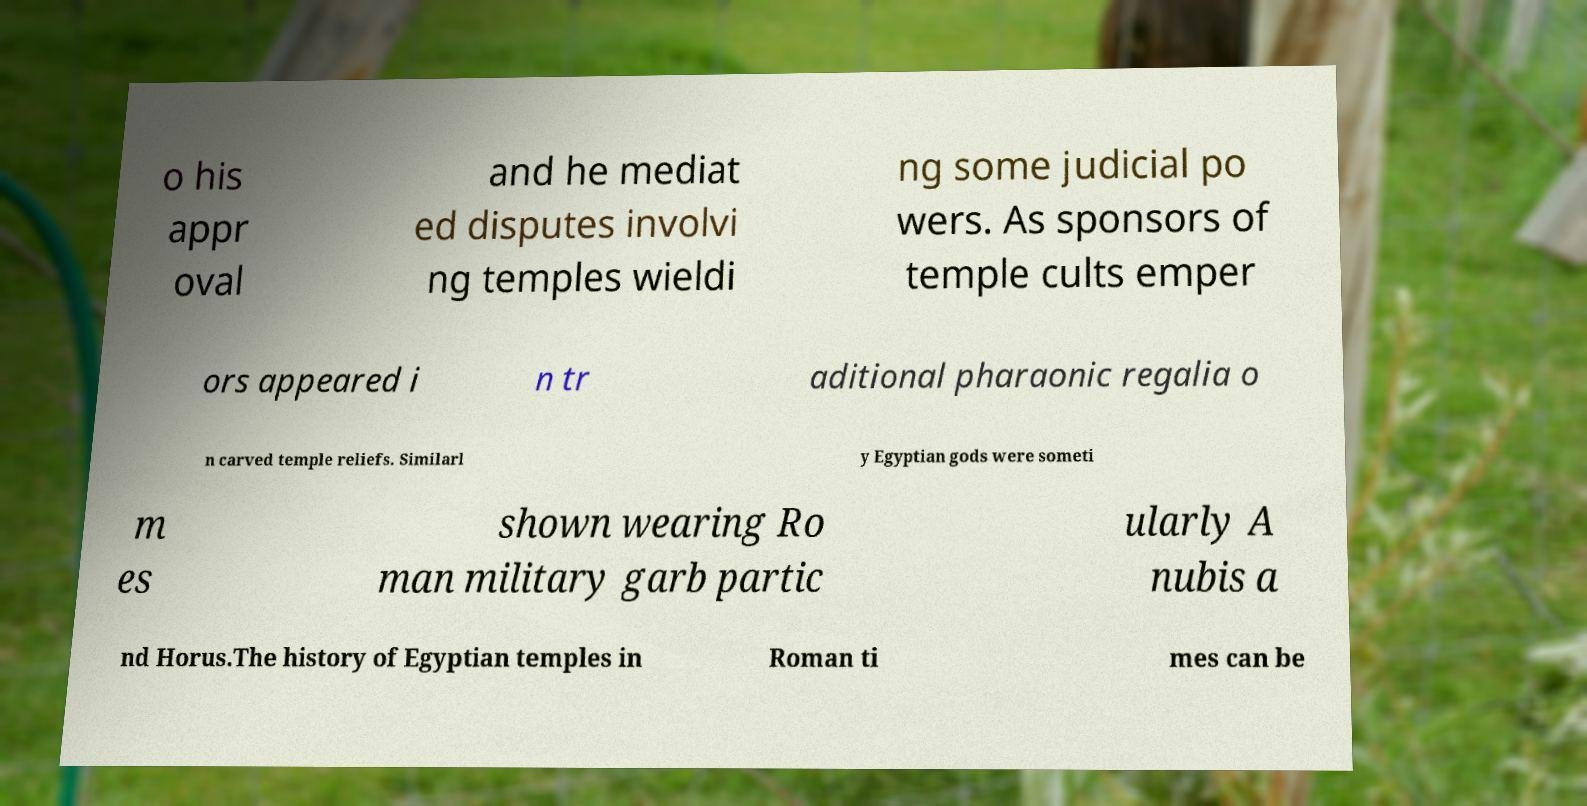Please identify and transcribe the text found in this image. o his appr oval and he mediat ed disputes involvi ng temples wieldi ng some judicial po wers. As sponsors of temple cults emper ors appeared i n tr aditional pharaonic regalia o n carved temple reliefs. Similarl y Egyptian gods were someti m es shown wearing Ro man military garb partic ularly A nubis a nd Horus.The history of Egyptian temples in Roman ti mes can be 